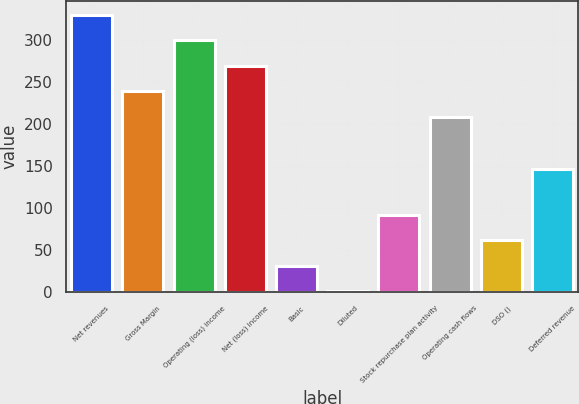Convert chart. <chart><loc_0><loc_0><loc_500><loc_500><bar_chart><fcel>Net revenues<fcel>Gross Margin<fcel>Operating (loss) income<fcel>Net (loss) income<fcel>Basic<fcel>Diluted<fcel>Stock repurchase plan activity<fcel>Operating cash flows<fcel>DSO ()<fcel>Deferred revenue<nl><fcel>329.48<fcel>238.52<fcel>299.16<fcel>268.84<fcel>30.83<fcel>0.51<fcel>91.47<fcel>208.2<fcel>61.15<fcel>145.9<nl></chart> 